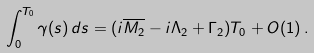Convert formula to latex. <formula><loc_0><loc_0><loc_500><loc_500>\int _ { 0 } ^ { T _ { 0 } } \gamma ( s ) \, d s = ( i \overline { M _ { 2 } } - i \Lambda _ { 2 } + \Gamma _ { 2 } ) T _ { 0 } + O ( 1 ) \, .</formula> 